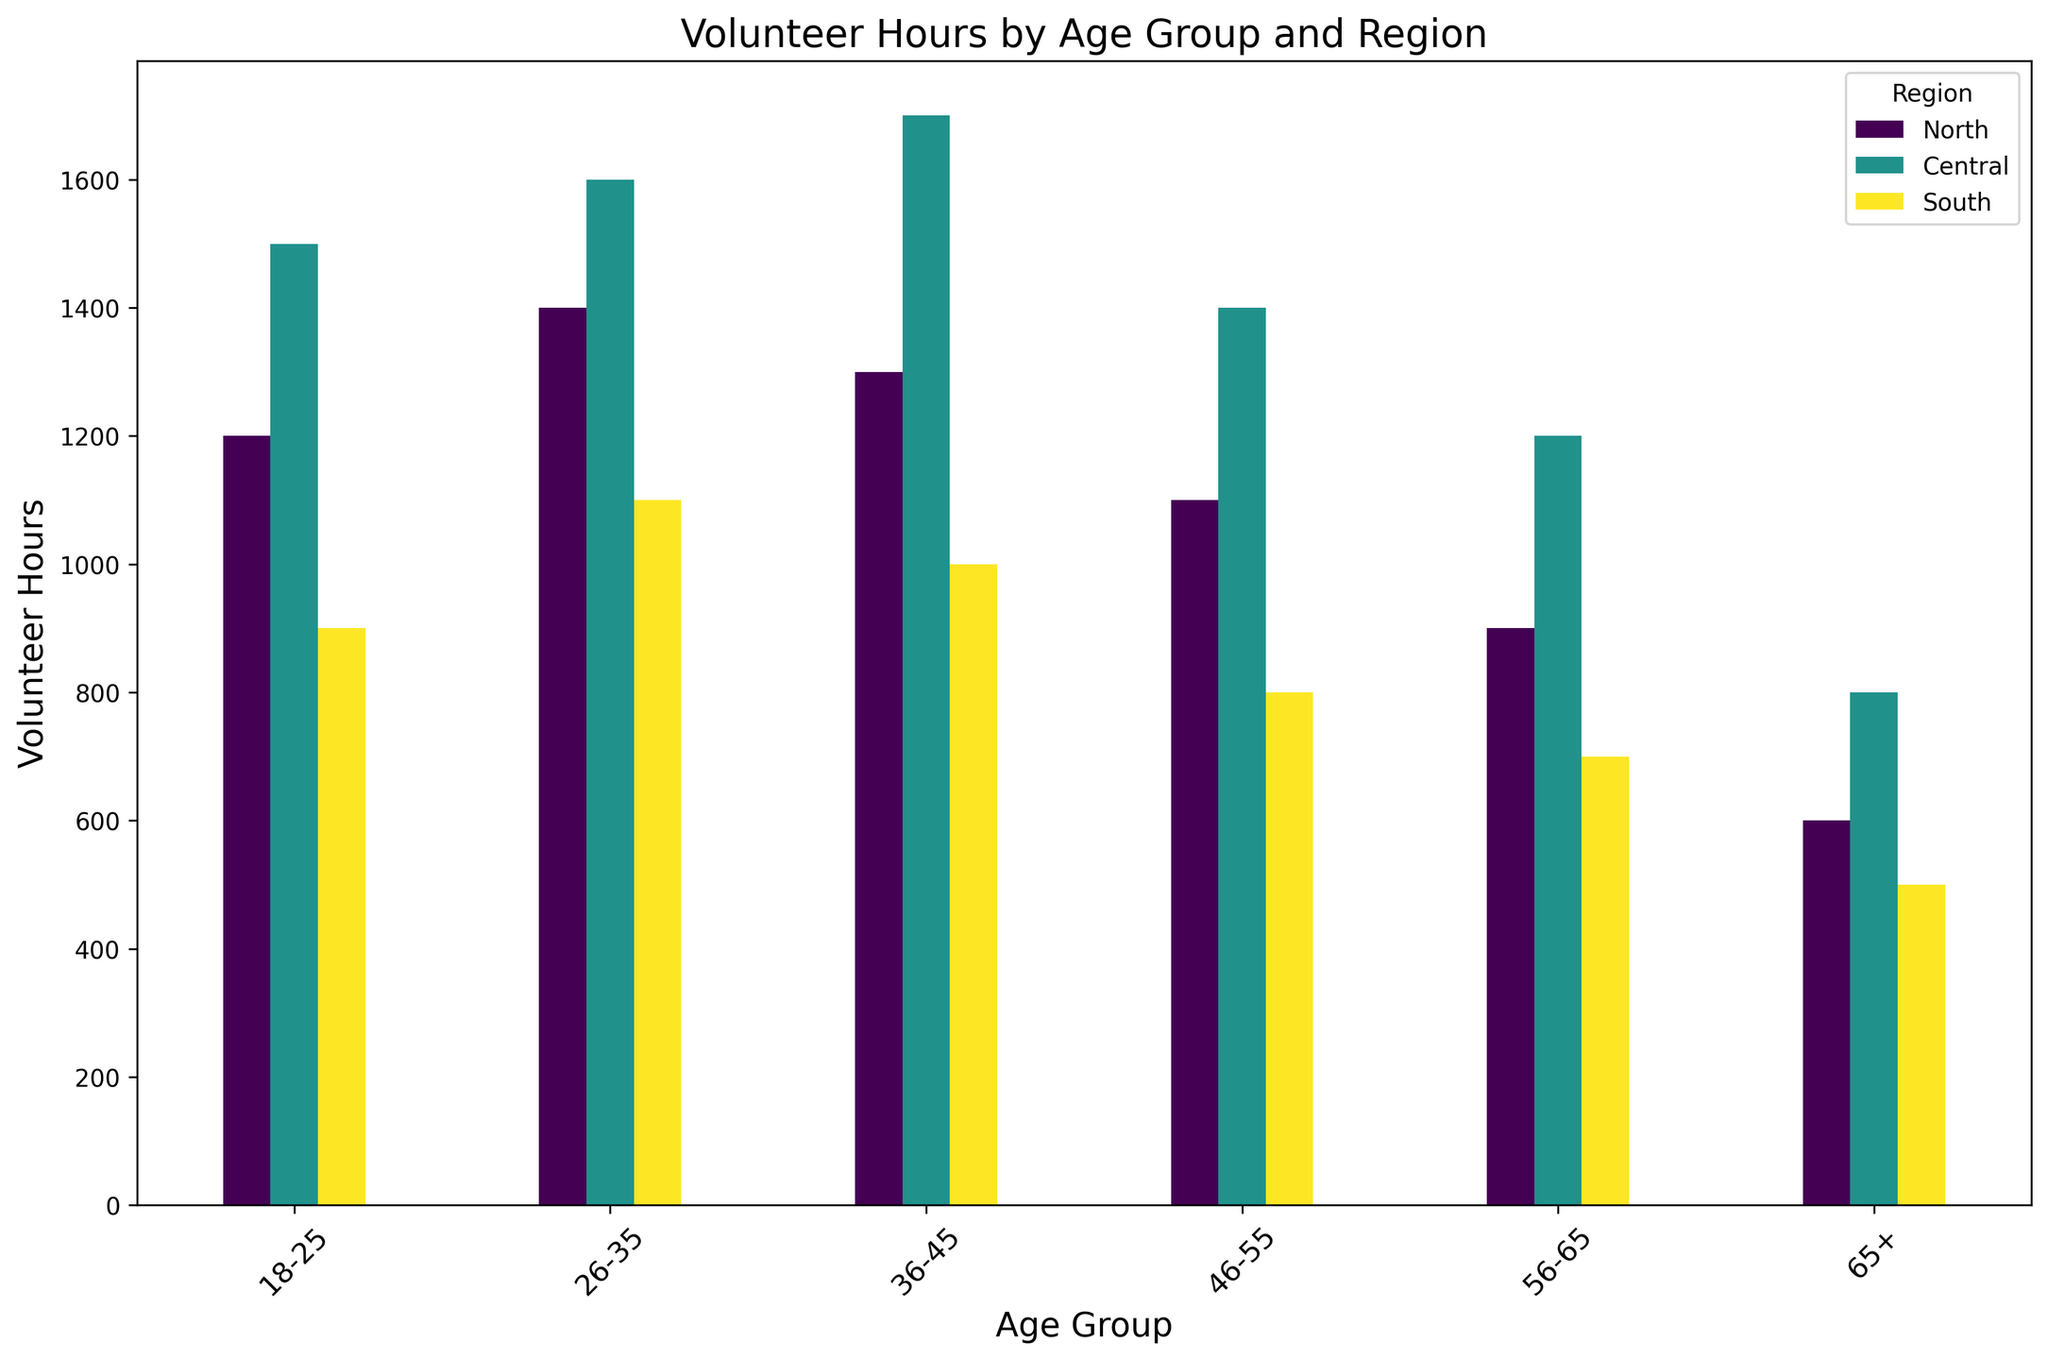What is the total number of volunteer hours contributed by people aged 26-35 across all regions? To find the total volunteer hours for the age group 26-35, look at the heights of the bars for the North, Central, and South regions under the 26-35 age group and sum them up. From the figure, these values are 1400 (North), 1600 (Central), and 1100 (South). Adding these numbers gives 1400 + 1600 + 1100 = 4100.
Answer: 4100 Which region contributed the highest number of volunteer hours for the age group 18-25? To determine which region has the highest number of volunteer hours for the 18-25 age group, compare the heights of the bars under the 18-25 category for North, Central, and South regions. From the figure, the highest bar corresponds to the Central region with 1500 hours.
Answer: Central What is the difference in volunteer hours between the Central and South regions for the age group 46-55? To find the difference, identify the volunteer hours for the Central and South regions under the 46-55 age group. From the figure, Central is 1400 hours and South is 800 hours. Subtracting the South's hours from Central's gives 1400 - 800 = 600.
Answer: 600 For the age group 65+, which region has the least number of volunteer hours, and how many hours were contributed? Look at the bars under the 65+ age group and identify which bar is the shortest. The South region has the shortest bar with 500 volunteer hours.
Answer: South, 500 How many more volunteer hours did the age group 36-45 contribute in the Central region compared to the age group 65+ in the same region? To find out, identify the volunteer hours for Central region for the age groups 36-45 and 65+. From the figure, the 36-45 age group contributed 1700 hours, and the 65+ age group contributed 800 hours. The difference is 1700 - 800 = 900.
Answer: 900 Which age group contributed the most volunteer hours in the North region? To find out which age group contributed the most hours in the North region, compare the heights of the bars corresponding to different age groups under the North region. From the figure, the age group 26-35 has the tallest bar with 1400 hours.
Answer: 26-35 Among all regions, which age group has the most evenly distributed volunteer hours? To determine which age group has the most evenly distributed volunteer hours, compare the height differences of the bars within each age group across all regions. The 65+ age group has the smallest difference in height among North (600), Central (800), and South (500). This indicates more evenly distributed volunteer hours.
Answer: 65+ How many volunteer hours were contributed by the 56-65 age group in the South region? Look at the height of the bar for the 56-65 age group under the South region in the figure. The height corresponds to 700 volunteer hours.
Answer: 700 Among the age groups 18-25 and 46-55, which one has a closer total sum of volunteer hours across all regions? Provide the sums for both. For age group 18-25, sum the heights of the three bars: 1200 (North) + 1500 (Central) + 900 (South) = 3600. For age group 46-55, sum the heights: 1100 (North) + 1400 (Central) + 800 (South) = 3300. The sums are 3600 and 3300 respectively, and 3300 (46-55) is closer.
Answer: 46-55, 3300 